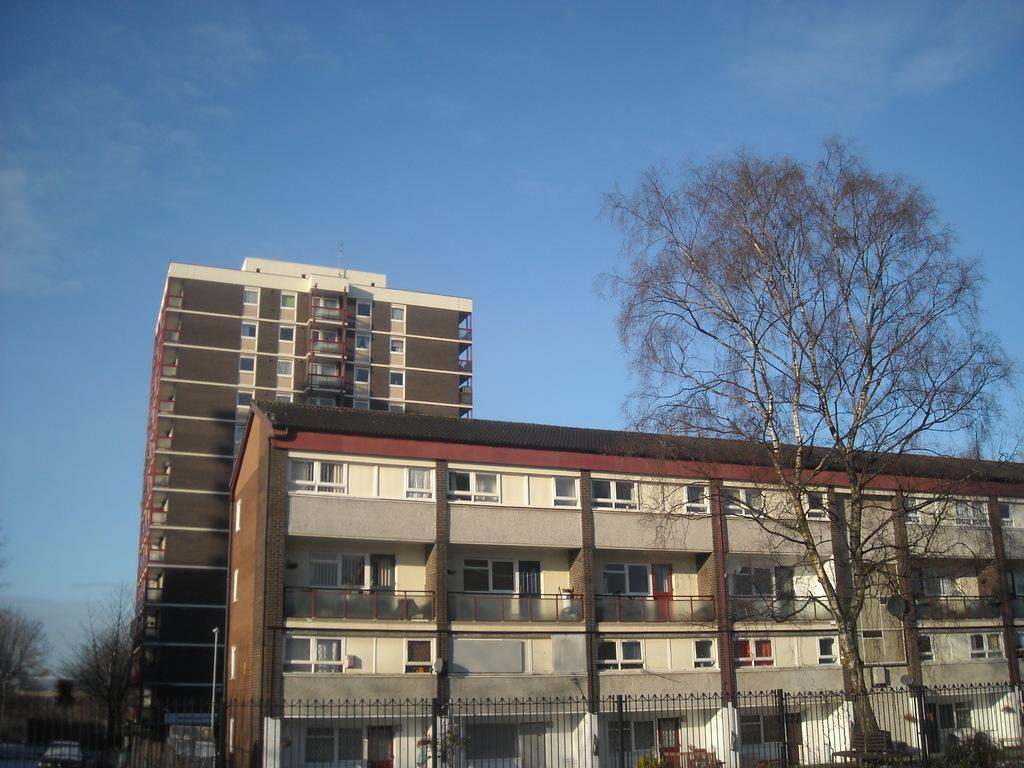In one or two sentences, can you explain what this image depicts? This image consists of buildings. On the left and right, we can see the trees. At the top, there is a sky in blue color. 